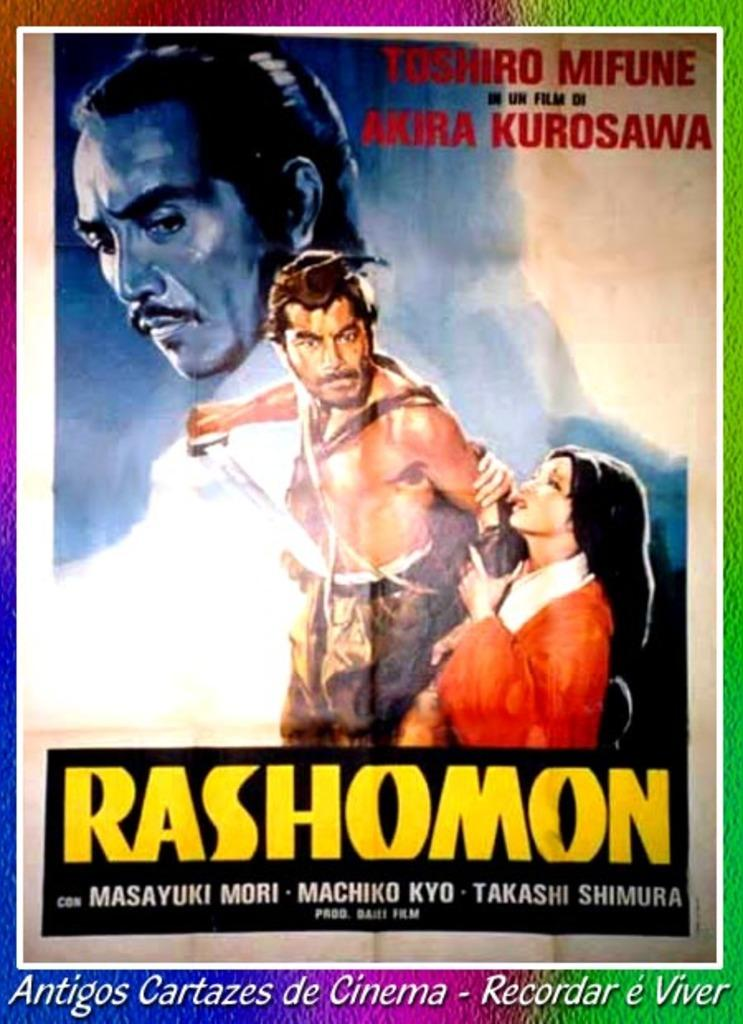Provide a one-sentence caption for the provided image. A movie poster for a vintage foreign movie called Rashomon. 